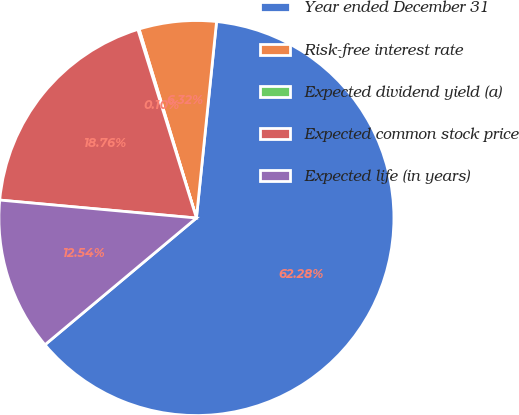<chart> <loc_0><loc_0><loc_500><loc_500><pie_chart><fcel>Year ended December 31<fcel>Risk-free interest rate<fcel>Expected dividend yield (a)<fcel>Expected common stock price<fcel>Expected life (in years)<nl><fcel>62.29%<fcel>6.32%<fcel>0.1%<fcel>18.76%<fcel>12.54%<nl></chart> 